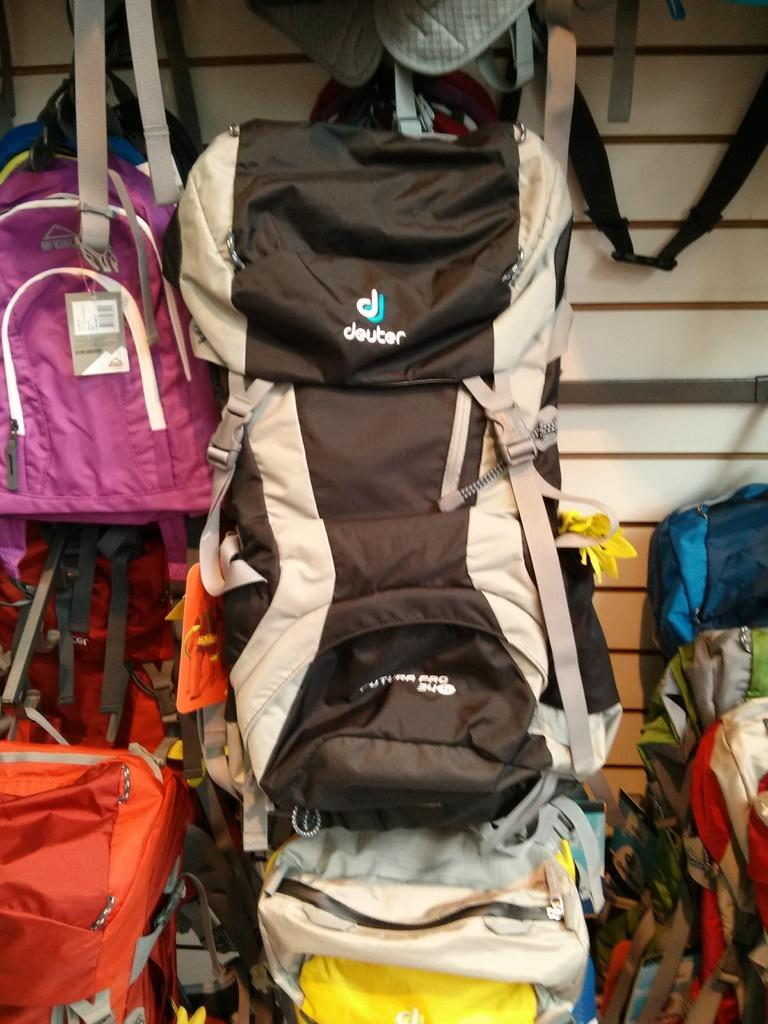<image>
Provide a brief description of the given image. a Deuter back pack hanging up on display with others 